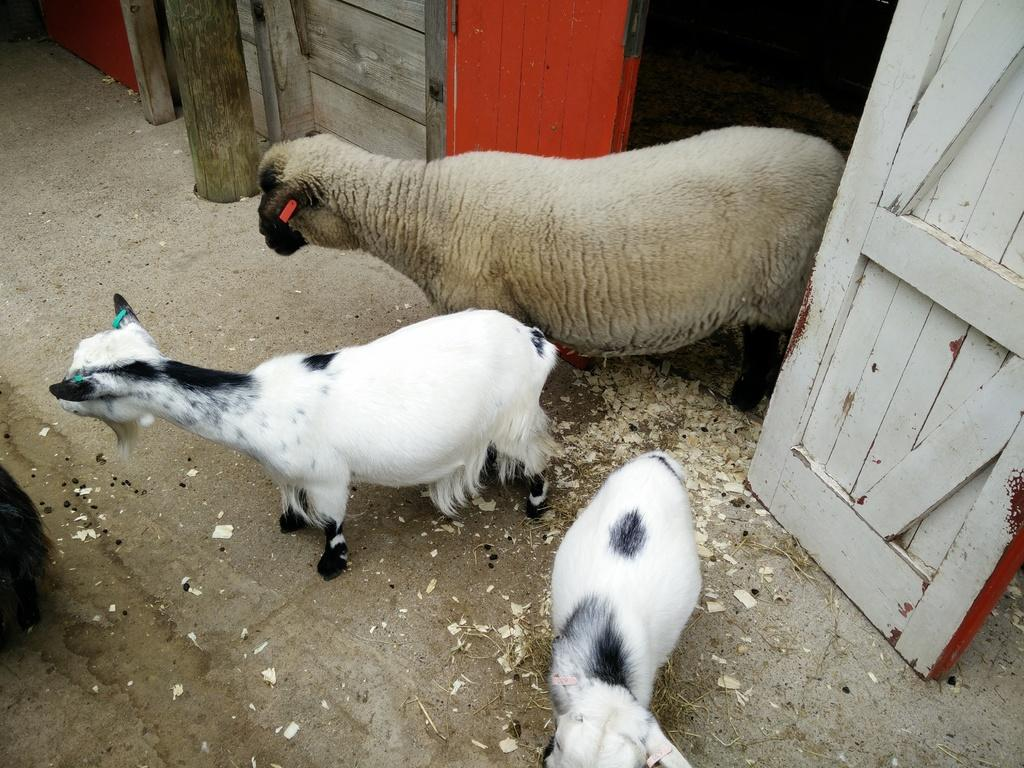What type of animal is present in the image? There is a sheep in the image. How many smaller animals are with the sheep? There are two lambs in the image. What type of structure can be seen in the image? There is a wooden house in the image. What type of plant is visible at the top side of the image? There is a bamboo at the top side of the image. What reasons are given for the sheep's behavior in the image? There are no reasons given for the sheep's behavior in the image, as it is a static image and does not depict any behavior. 